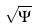<formula> <loc_0><loc_0><loc_500><loc_500>\sqrt { \Psi }</formula> 